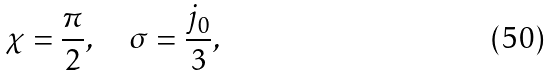<formula> <loc_0><loc_0><loc_500><loc_500>\chi = \frac { \pi } { 2 } , \quad \sigma = \frac { j _ { 0 } } { 3 } ,</formula> 